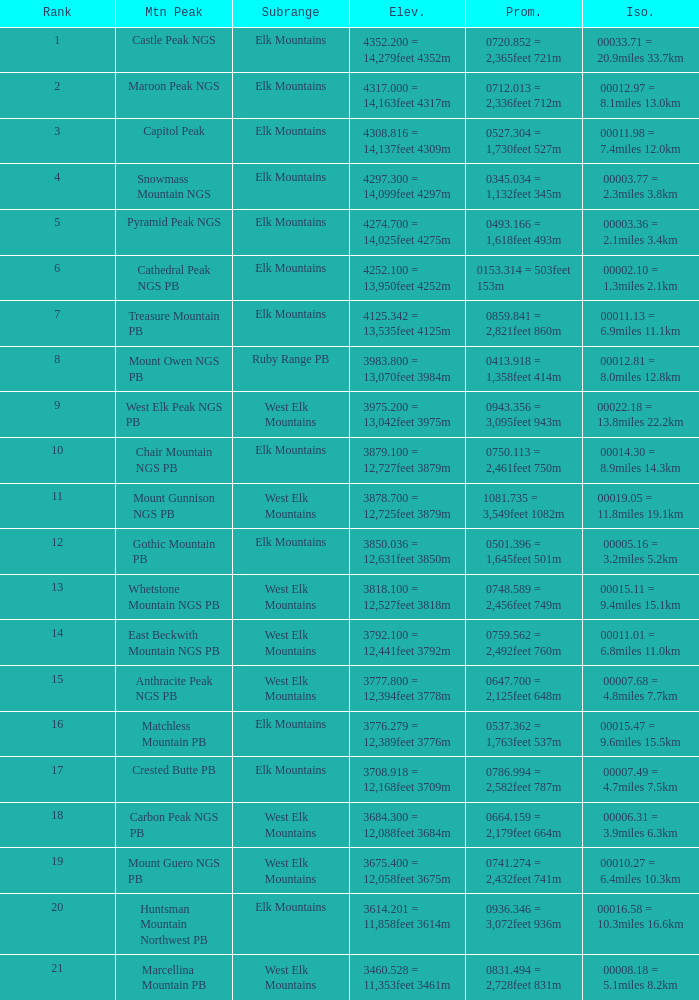Name the Rank of Rank Mountain Peak of crested butte pb? 17.0. 